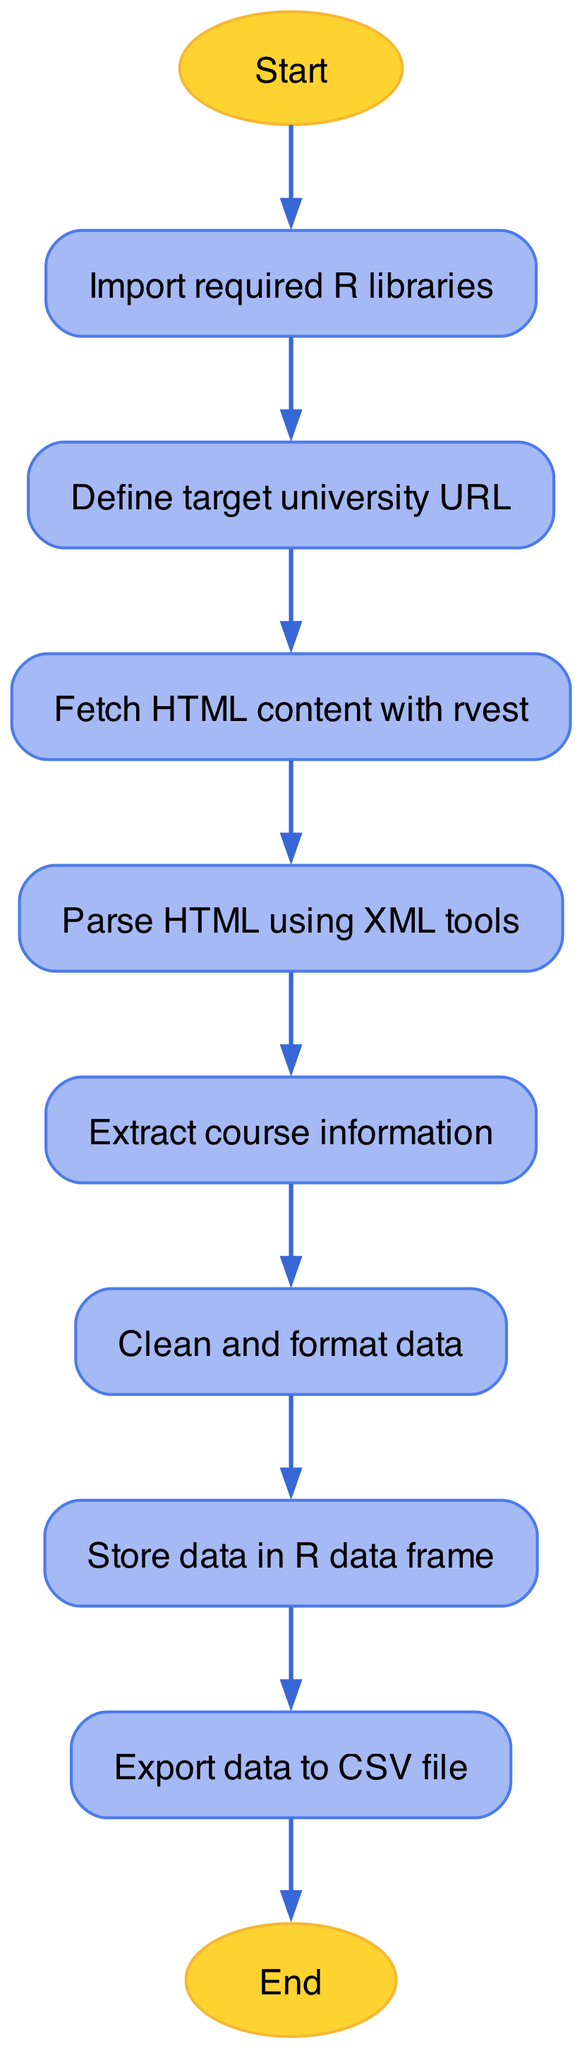What is the total number of nodes in the diagram? The diagram contains individual steps or processes related to web scraping represented as nodes. By counting all the nodes listed, we find there are ten nodes in total.
Answer: 10 What is the text in the 'store' node? The 'store' node, which indicates where the data collected will be saved, contains the text "Store data in R data frame".
Answer: Store data in R data frame Which node follows 'fetch' in the flow? By following the progression from the 'fetch' node, we see that it leads directly to the 'parse' node, which is the next step in the process.
Answer: parse What action precedes the 'end' node? Looking at the flow, the last action before reaching the 'end' node is the export of data to a CSV file, indicated by the 'export' node.
Answer: Export data to CSV file How many edges are there connecting the nodes? The edges represent the connections or flow between nodes. By counting all the edges defined in the diagram, we find there are nine edges linking the nodes together.
Answer: 9 What is the primary function of the 'clean' node? The 'clean' node serves a specific purpose in the web scraping process, which is to "Clean and format data", ensuring that the extracted information is usable and organized.
Answer: Clean and format data Which node is the starting point of the diagram? The diagram clearly indicates that the starting point of the process is the 'start' node, which signifies the beginning of the web scraping script.
Answer: Start Which node is the last step before finishing the process? Analyzing the flow of the diagram, we can identify that the last step before finishing is the 'export' node, where the collected data is saved to a file.
Answer: Export data to CSV file What is required before defining the target university URL? According to the flowchart, the action necessary before defining the university URL is to "Import required R libraries", which gives the needed tools to proceed with web scraping.
Answer: Import required R libraries 